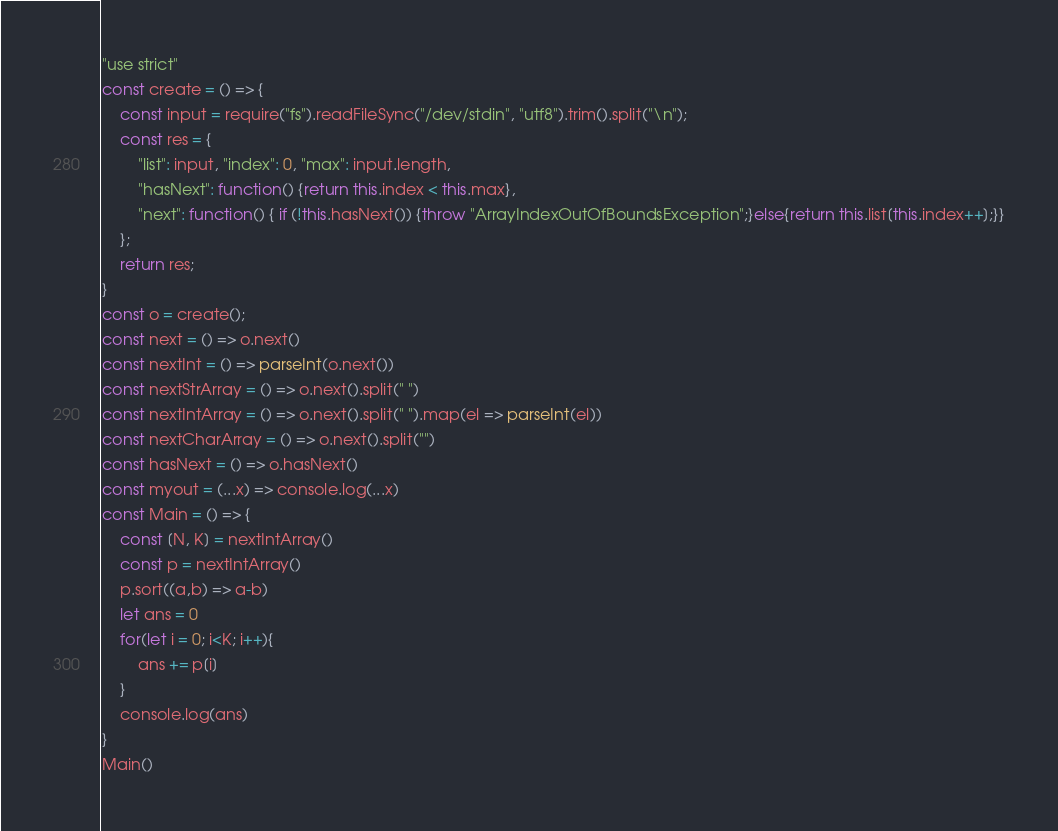<code> <loc_0><loc_0><loc_500><loc_500><_JavaScript_>"use strict"
const create = () => {
    const input = require("fs").readFileSync("/dev/stdin", "utf8").trim().split("\n");
    const res = {
        "list": input, "index": 0, "max": input.length,
        "hasNext": function() {return this.index < this.max},
        "next": function() { if (!this.hasNext()) {throw "ArrayIndexOutOfBoundsException";}else{return this.list[this.index++];}}
    };
    return res;
}
const o = create();
const next = () => o.next()
const nextInt = () => parseInt(o.next())
const nextStrArray = () => o.next().split(" ")
const nextIntArray = () => o.next().split(" ").map(el => parseInt(el))
const nextCharArray = () => o.next().split("")
const hasNext = () => o.hasNext()
const myout = (...x) => console.log(...x)
const Main = () => {
    const [N, K] = nextIntArray()
    const p = nextIntArray()
    p.sort((a,b) => a-b)
    let ans = 0
    for(let i = 0; i<K; i++){
        ans += p[i]
    }
    console.log(ans)
}
Main()
</code> 